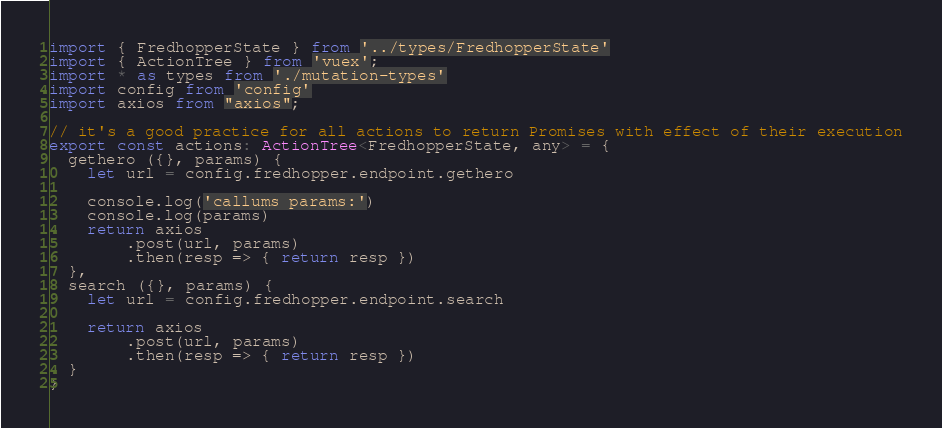Convert code to text. <code><loc_0><loc_0><loc_500><loc_500><_TypeScript_>import { FredhopperState } from '../types/FredhopperState'
import { ActionTree } from 'vuex';
import * as types from './mutation-types'
import config from 'config'
import axios from "axios";

// it's a good practice for all actions to return Promises with effect of their execution
export const actions: ActionTree<FredhopperState, any> = {
  gethero ({}, params) {
    let url = config.fredhopper.endpoint.gethero

    console.log('callums params:')
    console.log(params)
    return axios
        .post(url, params)
        .then(resp => { return resp })
  },
  search ({}, params) {
    let url = config.fredhopper.endpoint.search

    return axios
        .post(url, params)
        .then(resp => { return resp })
  }
}
</code> 